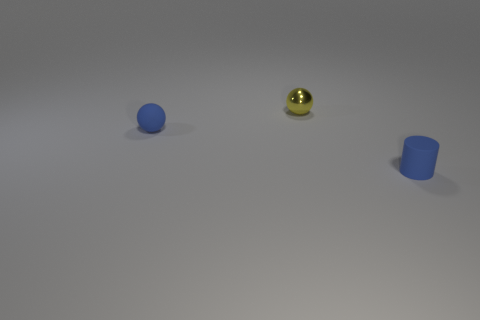Subtract all cylinders. How many objects are left? 2 Subtract all yellow balls. How many balls are left? 1 Add 2 yellow metal things. How many objects exist? 5 Subtract 1 spheres. How many spheres are left? 1 Add 1 matte balls. How many matte balls are left? 2 Add 3 big brown metallic spheres. How many big brown metallic spheres exist? 3 Subtract 0 blue cubes. How many objects are left? 3 Subtract all brown cylinders. Subtract all cyan spheres. How many cylinders are left? 1 Subtract all red matte spheres. Subtract all blue matte objects. How many objects are left? 1 